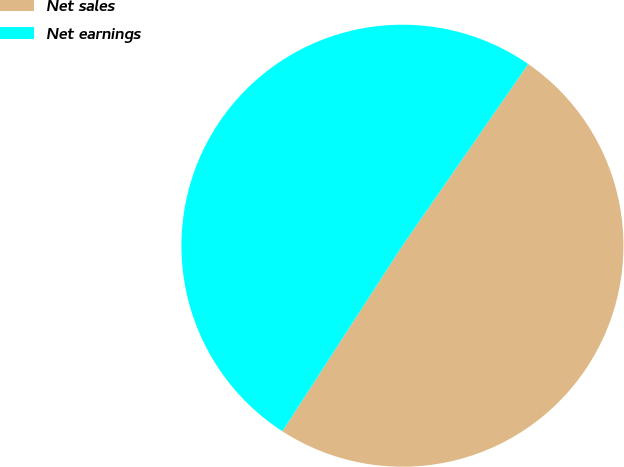Convert chart to OTSL. <chart><loc_0><loc_0><loc_500><loc_500><pie_chart><fcel>Net sales<fcel>Net earnings<nl><fcel>49.5%<fcel>50.5%<nl></chart> 